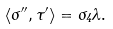Convert formula to latex. <formula><loc_0><loc_0><loc_500><loc_500>\langle \sigma ^ { \prime \prime } , \tau ^ { \prime } \rangle = \sigma _ { 4 } \lambda .</formula> 